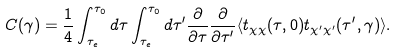<formula> <loc_0><loc_0><loc_500><loc_500>C ( \gamma ) = \frac { 1 } { 4 } \int _ { \tau _ { e } } ^ { \tau _ { 0 } } d \tau \int _ { \tau _ { e } } ^ { \tau _ { 0 } } d \tau ^ { \prime } \frac { \partial } { \partial \tau } \frac { \partial } { \partial \tau ^ { \prime } } \langle t _ { \chi \chi } ( \tau , 0 ) t _ { \chi ^ { \prime } \chi ^ { \prime } } ( \tau ^ { \prime } , \gamma ) \rangle .</formula> 